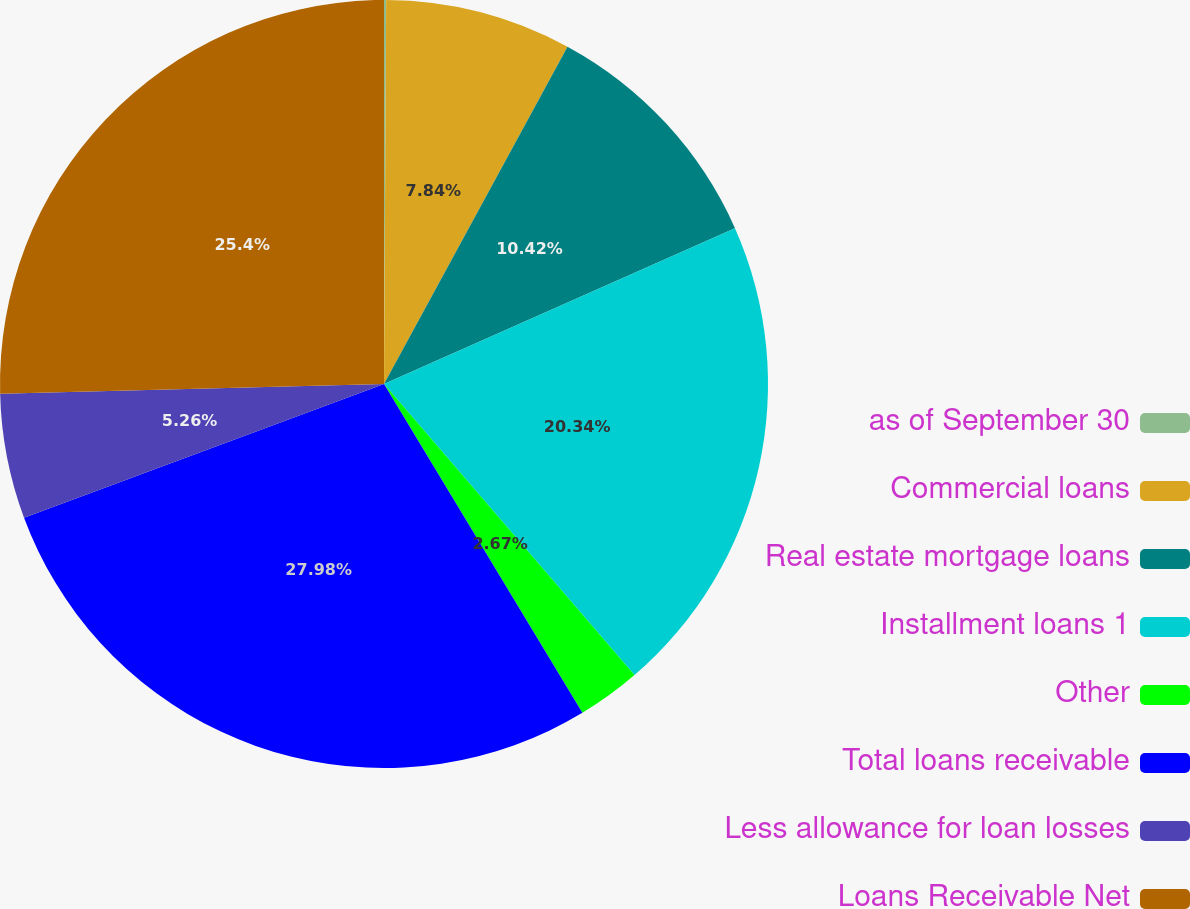<chart> <loc_0><loc_0><loc_500><loc_500><pie_chart><fcel>as of September 30<fcel>Commercial loans<fcel>Real estate mortgage loans<fcel>Installment loans 1<fcel>Other<fcel>Total loans receivable<fcel>Less allowance for loan losses<fcel>Loans Receivable Net<nl><fcel>0.09%<fcel>7.84%<fcel>10.42%<fcel>20.34%<fcel>2.67%<fcel>27.98%<fcel>5.26%<fcel>25.4%<nl></chart> 